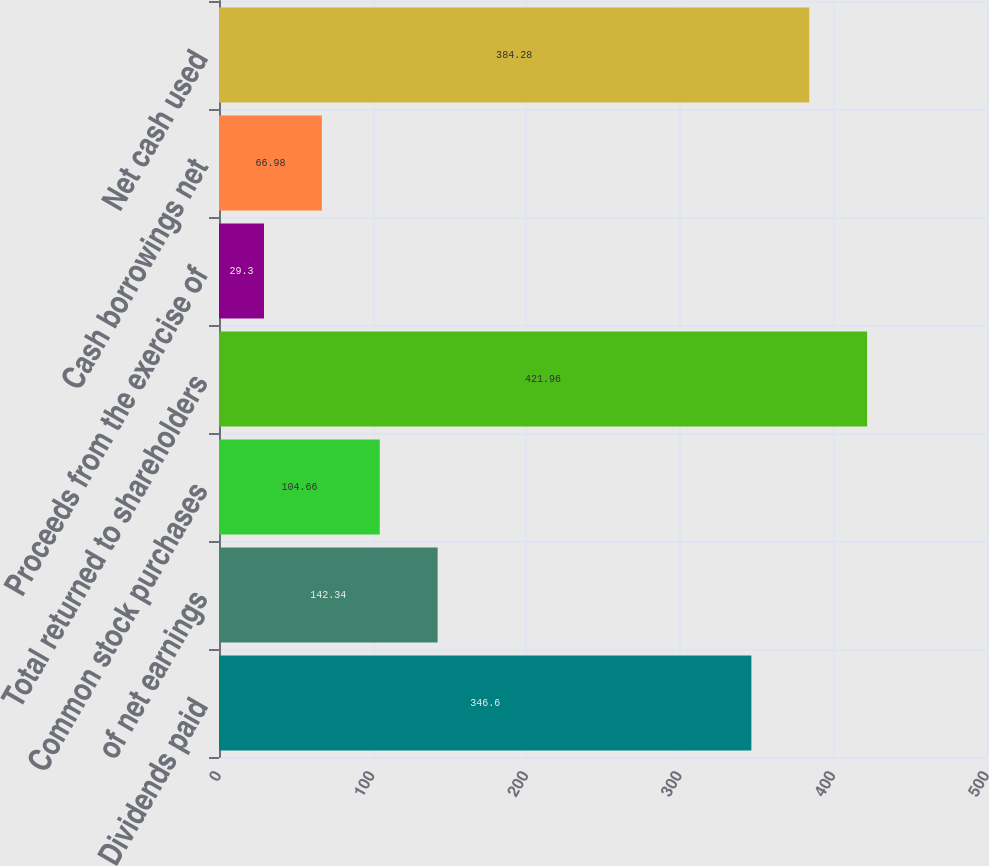Convert chart to OTSL. <chart><loc_0><loc_0><loc_500><loc_500><bar_chart><fcel>Dividends paid<fcel>of net earnings<fcel>Common stock purchases<fcel>Total returned to shareholders<fcel>Proceeds from the exercise of<fcel>Cash borrowings net<fcel>Net cash used<nl><fcel>346.6<fcel>142.34<fcel>104.66<fcel>421.96<fcel>29.3<fcel>66.98<fcel>384.28<nl></chart> 